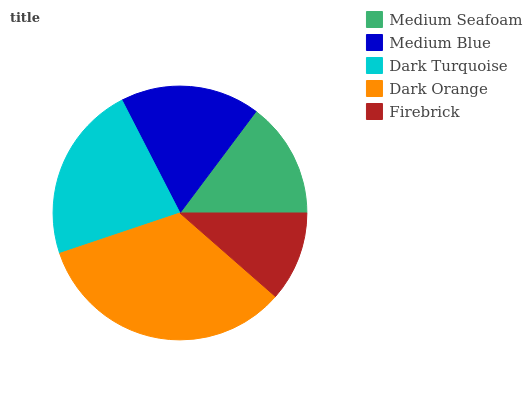Is Firebrick the minimum?
Answer yes or no. Yes. Is Dark Orange the maximum?
Answer yes or no. Yes. Is Medium Blue the minimum?
Answer yes or no. No. Is Medium Blue the maximum?
Answer yes or no. No. Is Medium Blue greater than Medium Seafoam?
Answer yes or no. Yes. Is Medium Seafoam less than Medium Blue?
Answer yes or no. Yes. Is Medium Seafoam greater than Medium Blue?
Answer yes or no. No. Is Medium Blue less than Medium Seafoam?
Answer yes or no. No. Is Medium Blue the high median?
Answer yes or no. Yes. Is Medium Blue the low median?
Answer yes or no. Yes. Is Dark Orange the high median?
Answer yes or no. No. Is Dark Orange the low median?
Answer yes or no. No. 